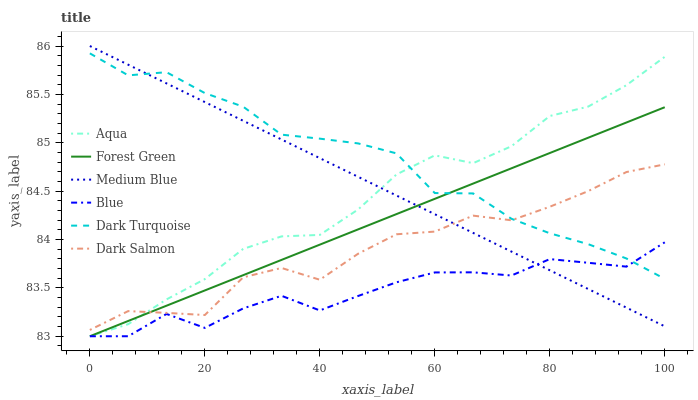Does Blue have the minimum area under the curve?
Answer yes or no. Yes. Does Dark Turquoise have the maximum area under the curve?
Answer yes or no. Yes. Does Aqua have the minimum area under the curve?
Answer yes or no. No. Does Aqua have the maximum area under the curve?
Answer yes or no. No. Is Medium Blue the smoothest?
Answer yes or no. Yes. Is Blue the roughest?
Answer yes or no. Yes. Is Aqua the smoothest?
Answer yes or no. No. Is Aqua the roughest?
Answer yes or no. No. Does Blue have the lowest value?
Answer yes or no. Yes. Does Medium Blue have the lowest value?
Answer yes or no. No. Does Medium Blue have the highest value?
Answer yes or no. Yes. Does Aqua have the highest value?
Answer yes or no. No. Is Blue less than Dark Salmon?
Answer yes or no. Yes. Is Dark Salmon greater than Blue?
Answer yes or no. Yes. Does Dark Turquoise intersect Forest Green?
Answer yes or no. Yes. Is Dark Turquoise less than Forest Green?
Answer yes or no. No. Is Dark Turquoise greater than Forest Green?
Answer yes or no. No. Does Blue intersect Dark Salmon?
Answer yes or no. No. 